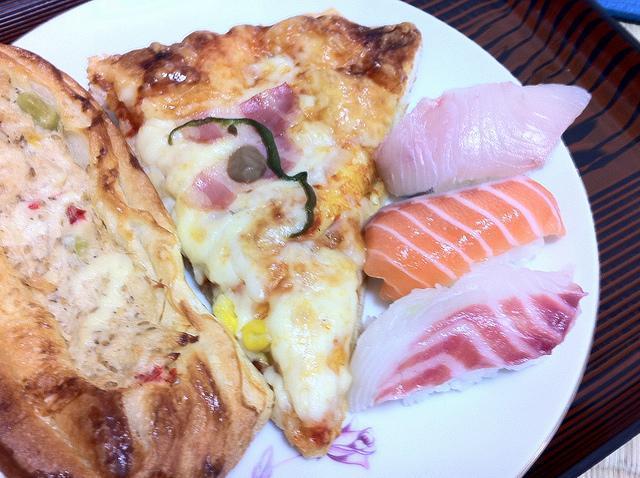How many pizzas are in the picture?
Give a very brief answer. 2. How many women can you see?
Give a very brief answer. 0. 